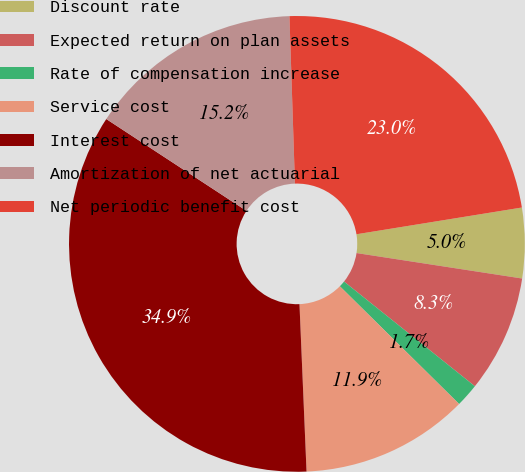Convert chart. <chart><loc_0><loc_0><loc_500><loc_500><pie_chart><fcel>Discount rate<fcel>Expected return on plan assets<fcel>Rate of compensation increase<fcel>Service cost<fcel>Interest cost<fcel>Amortization of net actuarial<fcel>Net periodic benefit cost<nl><fcel>4.98%<fcel>8.31%<fcel>1.66%<fcel>11.93%<fcel>34.9%<fcel>15.25%<fcel>22.97%<nl></chart> 